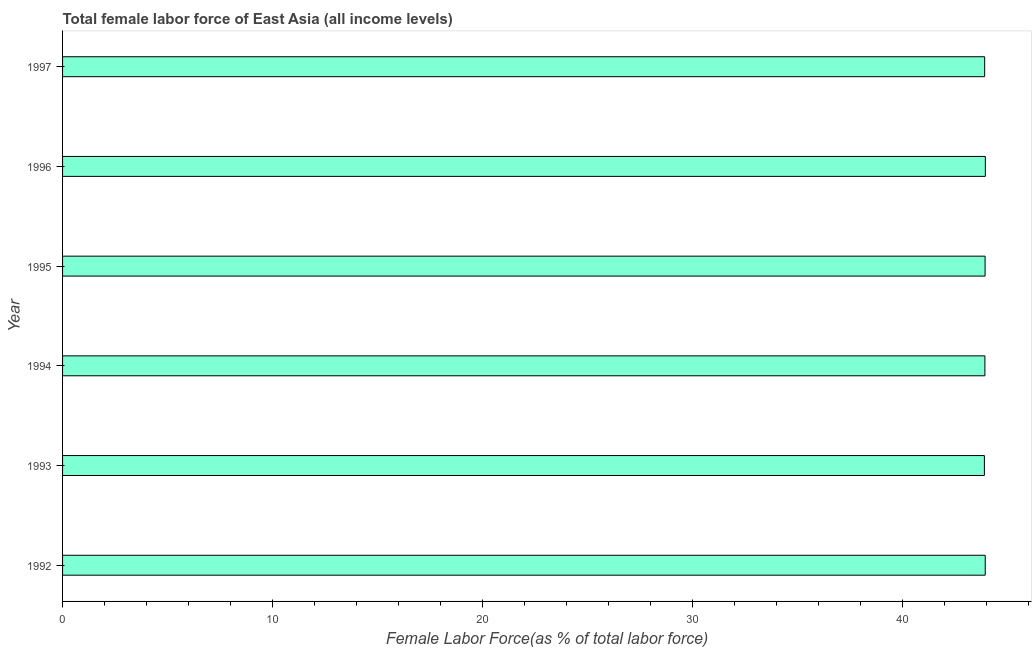What is the title of the graph?
Keep it short and to the point. Total female labor force of East Asia (all income levels). What is the label or title of the X-axis?
Provide a short and direct response. Female Labor Force(as % of total labor force). What is the total female labor force in 1995?
Your answer should be very brief. 43.92. Across all years, what is the maximum total female labor force?
Make the answer very short. 43.93. Across all years, what is the minimum total female labor force?
Ensure brevity in your answer.  43.88. In which year was the total female labor force maximum?
Provide a short and direct response. 1996. In which year was the total female labor force minimum?
Your answer should be very brief. 1993. What is the sum of the total female labor force?
Keep it short and to the point. 263.45. What is the difference between the total female labor force in 1996 and 1997?
Make the answer very short. 0.03. What is the average total female labor force per year?
Offer a terse response. 43.91. What is the median total female labor force?
Ensure brevity in your answer.  43.91. In how many years, is the total female labor force greater than 26 %?
Keep it short and to the point. 6. What is the ratio of the total female labor force in 1993 to that in 1995?
Keep it short and to the point. 1. Is the total female labor force in 1993 less than that in 1997?
Your answer should be compact. Yes. What is the difference between the highest and the second highest total female labor force?
Keep it short and to the point. 0.01. How many bars are there?
Offer a very short reply. 6. Are all the bars in the graph horizontal?
Your answer should be very brief. Yes. How many years are there in the graph?
Give a very brief answer. 6. What is the difference between two consecutive major ticks on the X-axis?
Your answer should be very brief. 10. Are the values on the major ticks of X-axis written in scientific E-notation?
Make the answer very short. No. What is the Female Labor Force(as % of total labor force) of 1992?
Offer a terse response. 43.92. What is the Female Labor Force(as % of total labor force) in 1993?
Your response must be concise. 43.88. What is the Female Labor Force(as % of total labor force) in 1994?
Make the answer very short. 43.91. What is the Female Labor Force(as % of total labor force) in 1995?
Keep it short and to the point. 43.92. What is the Female Labor Force(as % of total labor force) of 1996?
Keep it short and to the point. 43.93. What is the Female Labor Force(as % of total labor force) in 1997?
Your answer should be compact. 43.9. What is the difference between the Female Labor Force(as % of total labor force) in 1992 and 1993?
Keep it short and to the point. 0.04. What is the difference between the Female Labor Force(as % of total labor force) in 1992 and 1994?
Offer a terse response. 0.02. What is the difference between the Female Labor Force(as % of total labor force) in 1992 and 1995?
Provide a short and direct response. 0.01. What is the difference between the Female Labor Force(as % of total labor force) in 1992 and 1996?
Provide a succinct answer. -0.01. What is the difference between the Female Labor Force(as % of total labor force) in 1992 and 1997?
Your response must be concise. 0.03. What is the difference between the Female Labor Force(as % of total labor force) in 1993 and 1994?
Your answer should be compact. -0.02. What is the difference between the Female Labor Force(as % of total labor force) in 1993 and 1995?
Give a very brief answer. -0.03. What is the difference between the Female Labor Force(as % of total labor force) in 1993 and 1996?
Keep it short and to the point. -0.05. What is the difference between the Female Labor Force(as % of total labor force) in 1993 and 1997?
Your answer should be compact. -0.01. What is the difference between the Female Labor Force(as % of total labor force) in 1994 and 1995?
Ensure brevity in your answer.  -0.01. What is the difference between the Female Labor Force(as % of total labor force) in 1994 and 1996?
Your response must be concise. -0.02. What is the difference between the Female Labor Force(as % of total labor force) in 1994 and 1997?
Offer a terse response. 0.01. What is the difference between the Female Labor Force(as % of total labor force) in 1995 and 1996?
Offer a very short reply. -0.01. What is the difference between the Female Labor Force(as % of total labor force) in 1995 and 1997?
Offer a terse response. 0.02. What is the difference between the Female Labor Force(as % of total labor force) in 1996 and 1997?
Ensure brevity in your answer.  0.03. What is the ratio of the Female Labor Force(as % of total labor force) in 1992 to that in 1994?
Provide a short and direct response. 1. What is the ratio of the Female Labor Force(as % of total labor force) in 1992 to that in 1995?
Offer a very short reply. 1. What is the ratio of the Female Labor Force(as % of total labor force) in 1992 to that in 1996?
Your answer should be compact. 1. What is the ratio of the Female Labor Force(as % of total labor force) in 1992 to that in 1997?
Offer a terse response. 1. What is the ratio of the Female Labor Force(as % of total labor force) in 1993 to that in 1994?
Your response must be concise. 1. What is the ratio of the Female Labor Force(as % of total labor force) in 1993 to that in 1995?
Offer a terse response. 1. What is the ratio of the Female Labor Force(as % of total labor force) in 1993 to that in 1996?
Your answer should be compact. 1. What is the ratio of the Female Labor Force(as % of total labor force) in 1993 to that in 1997?
Provide a short and direct response. 1. What is the ratio of the Female Labor Force(as % of total labor force) in 1994 to that in 1996?
Offer a very short reply. 1. What is the ratio of the Female Labor Force(as % of total labor force) in 1994 to that in 1997?
Your answer should be compact. 1. What is the ratio of the Female Labor Force(as % of total labor force) in 1995 to that in 1997?
Offer a terse response. 1. What is the ratio of the Female Labor Force(as % of total labor force) in 1996 to that in 1997?
Provide a short and direct response. 1. 